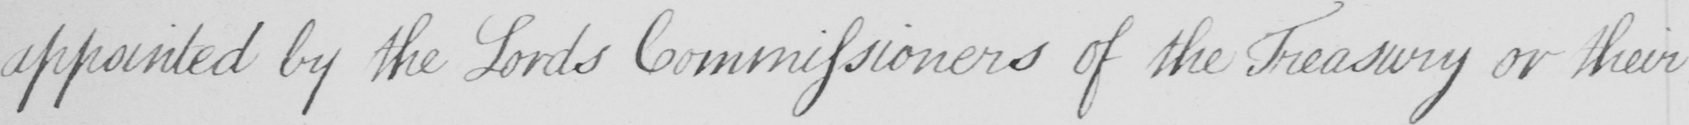What is written in this line of handwriting? appointed by the Lords Commissioners of the Treasury or their 